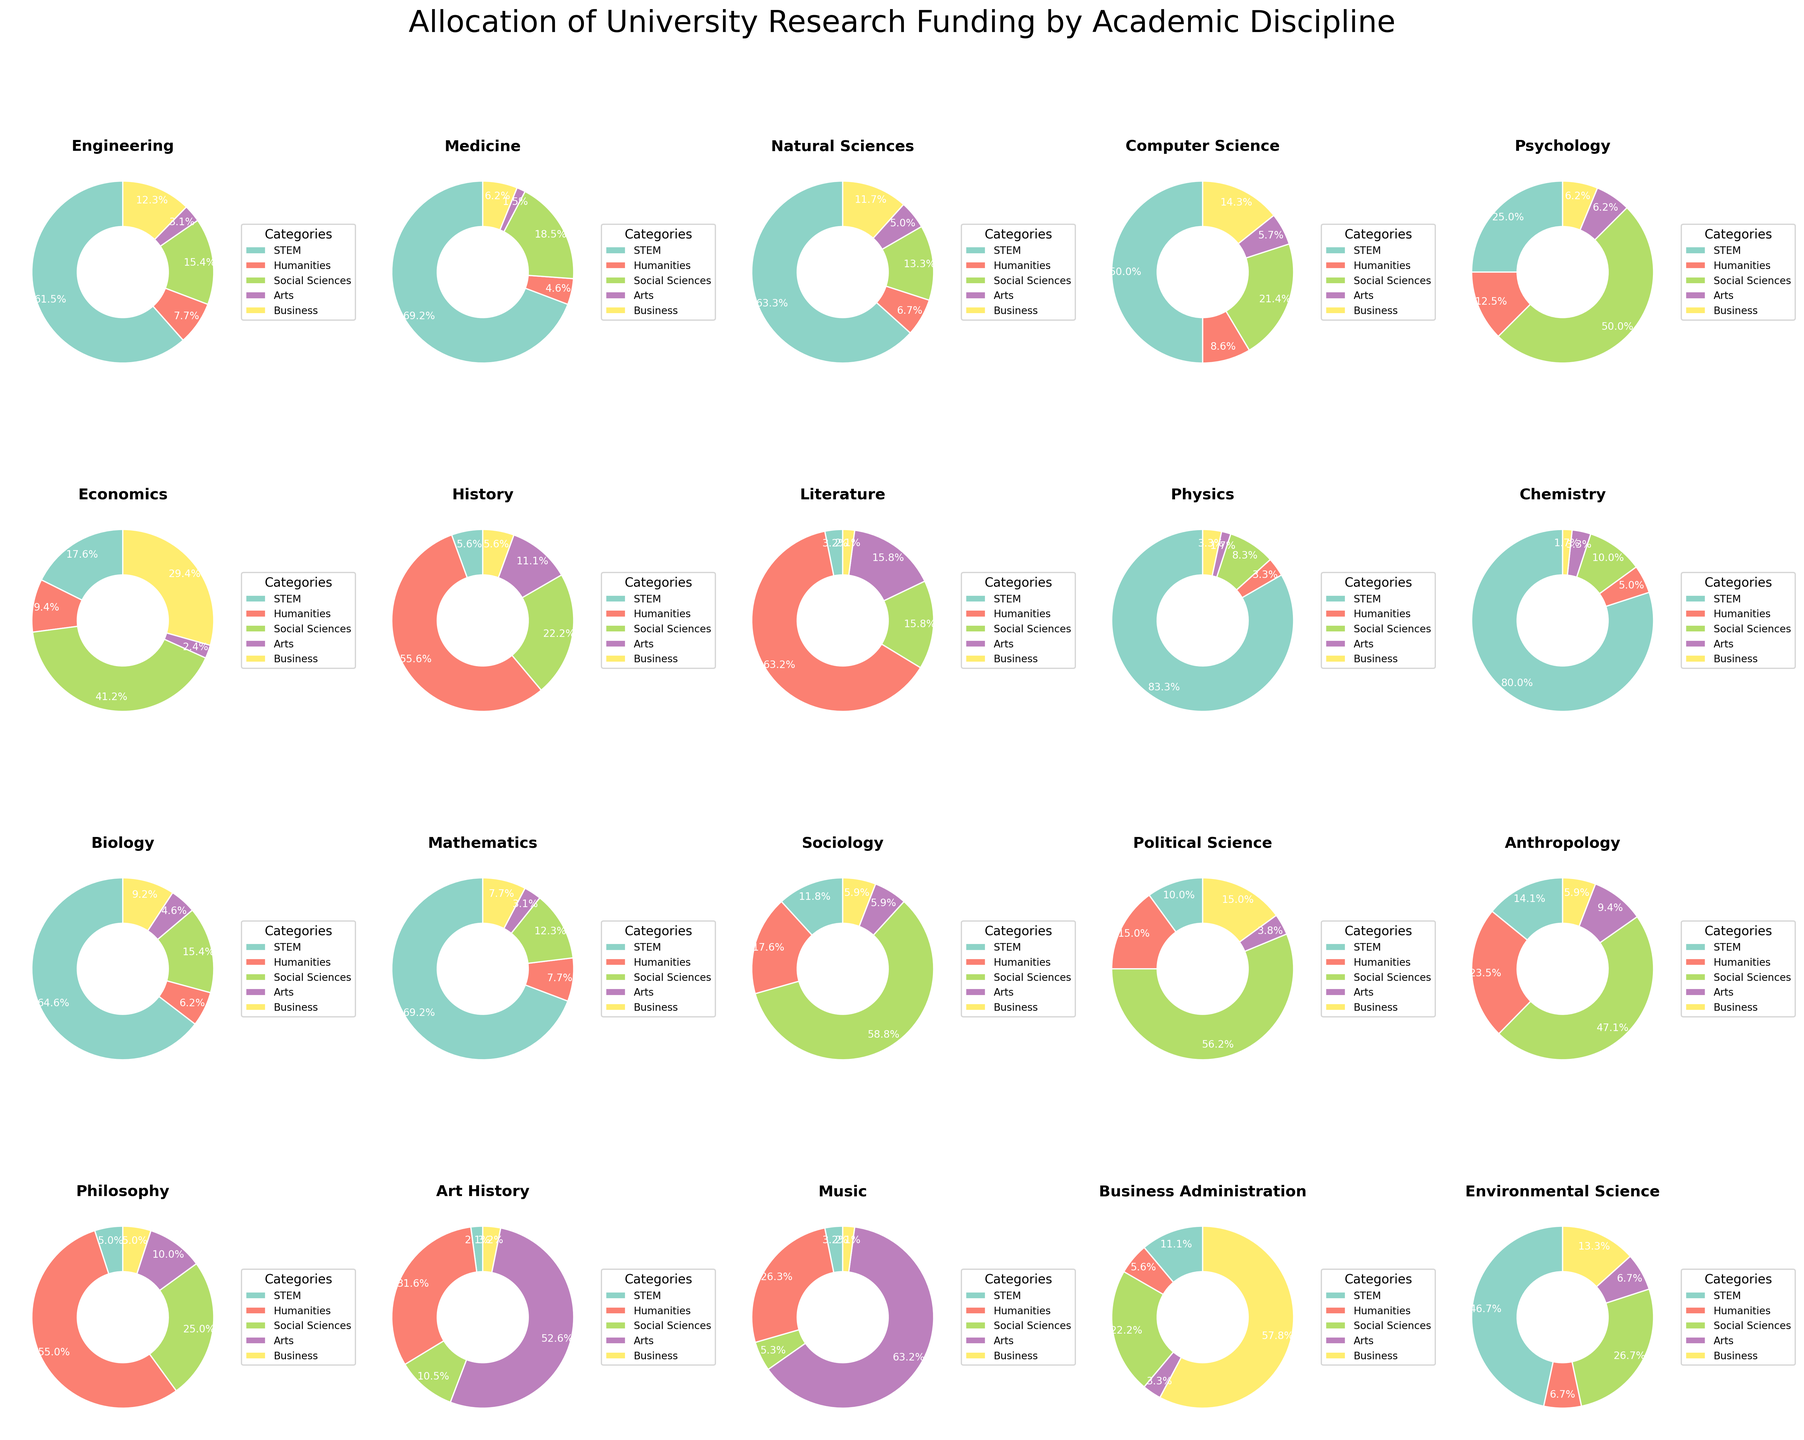Which discipline allocates the most funding to STEM? Look at the pie charts and check the segment representing STEM funding for each discipline. The one with the largest segment is the answer.
Answer: Physics Which discipline allocates the highest percentage of funding to the Humanities? Identify the pie chart with the largest slice labeled as Humanities.
Answer: Literature In which discipline does Social Sciences receive the most funding? Find the pie chart where the Social Sciences slice is the largest compared to other disciplines.
Answer: Sociology Compare the funding percentages for Arts and Business in Music. Which one is larger? Examine the pie chart for Music and compare the size of the segments for Arts and Business directly.
Answer: Arts What is the difference in STEM funding between Engineering and Mathematics? Find the STEM funding segments for Engineering and Mathematics, then subtract the smaller percentage from the larger one (40% for Engineering - 45% for Mathematics).
Answer: 5% Which discipline has the most balanced distribution of funding across all categories? Look for the pie chart with the segments being most evenly sized across all categories to determine the most balanced distribution.
Answer: Psychology Are there any disciplines where Arts funding exceeds 50%? If so, name them. Check each pie chart and identify any that have an Arts segment exceeding 50%.
Answer: Art History, Music How does the proportion of STEM funding in Biology compare to that in Environmental Science? Find the STEM segments in the Biology and Environmental Science pie charts and compare their sizes directly (42% for Biology vs. 35% for Environmental Science).
Answer: Biology has a higher STEM proportion Sum the funding percentages for Social Sciences and Business in Business Administration. Add the Social Sciences and Business percentages from the Business Administration pie chart (20% + 52%).
Answer: 72% Which discipline gives the lowest percentage of funding to the Humanities? Examine all pie charts to find the smallest segment labeled Humanities.
Answer: Physics 